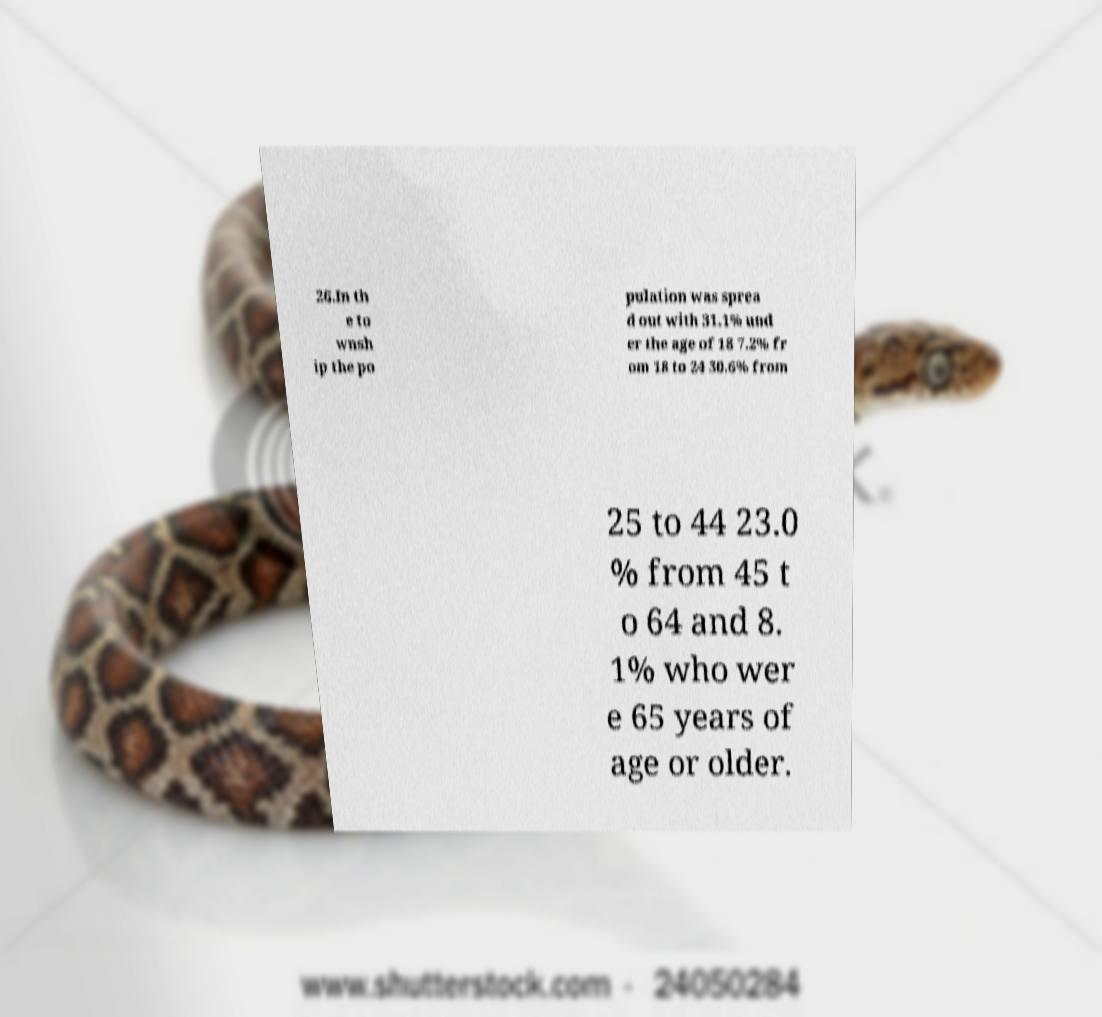There's text embedded in this image that I need extracted. Can you transcribe it verbatim? 26.In th e to wnsh ip the po pulation was sprea d out with 31.1% und er the age of 18 7.2% fr om 18 to 24 30.6% from 25 to 44 23.0 % from 45 t o 64 and 8. 1% who wer e 65 years of age or older. 